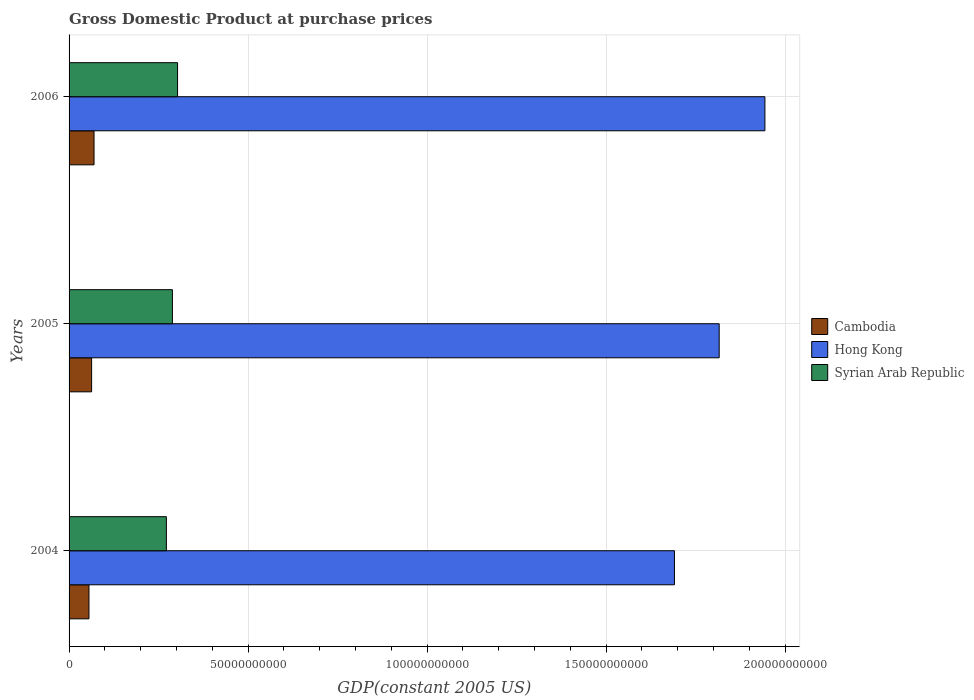Are the number of bars per tick equal to the number of legend labels?
Your response must be concise. Yes. How many bars are there on the 3rd tick from the top?
Keep it short and to the point. 3. How many bars are there on the 3rd tick from the bottom?
Offer a terse response. 3. In how many cases, is the number of bars for a given year not equal to the number of legend labels?
Offer a terse response. 0. What is the GDP at purchase prices in Syrian Arab Republic in 2006?
Offer a terse response. 3.03e+1. Across all years, what is the maximum GDP at purchase prices in Syrian Arab Republic?
Provide a succinct answer. 3.03e+1. Across all years, what is the minimum GDP at purchase prices in Syrian Arab Republic?
Ensure brevity in your answer.  2.72e+1. In which year was the GDP at purchase prices in Syrian Arab Republic maximum?
Keep it short and to the point. 2006. In which year was the GDP at purchase prices in Hong Kong minimum?
Offer a terse response. 2004. What is the total GDP at purchase prices in Hong Kong in the graph?
Your answer should be very brief. 5.45e+11. What is the difference between the GDP at purchase prices in Cambodia in 2005 and that in 2006?
Offer a very short reply. -6.78e+08. What is the difference between the GDP at purchase prices in Syrian Arab Republic in 2004 and the GDP at purchase prices in Cambodia in 2006?
Provide a short and direct response. 2.02e+1. What is the average GDP at purchase prices in Cambodia per year?
Give a very brief answer. 6.27e+09. In the year 2005, what is the difference between the GDP at purchase prices in Hong Kong and GDP at purchase prices in Syrian Arab Republic?
Give a very brief answer. 1.53e+11. In how many years, is the GDP at purchase prices in Cambodia greater than 190000000000 US$?
Your answer should be compact. 0. What is the ratio of the GDP at purchase prices in Hong Kong in 2005 to that in 2006?
Your response must be concise. 0.93. Is the GDP at purchase prices in Syrian Arab Republic in 2004 less than that in 2006?
Offer a terse response. Yes. Is the difference between the GDP at purchase prices in Hong Kong in 2005 and 2006 greater than the difference between the GDP at purchase prices in Syrian Arab Republic in 2005 and 2006?
Your answer should be compact. No. What is the difference between the highest and the second highest GDP at purchase prices in Cambodia?
Your answer should be very brief. 6.78e+08. What is the difference between the highest and the lowest GDP at purchase prices in Syrian Arab Republic?
Offer a terse response. 3.13e+09. In how many years, is the GDP at purchase prices in Hong Kong greater than the average GDP at purchase prices in Hong Kong taken over all years?
Make the answer very short. 1. Is the sum of the GDP at purchase prices in Cambodia in 2004 and 2005 greater than the maximum GDP at purchase prices in Hong Kong across all years?
Your response must be concise. No. What does the 3rd bar from the top in 2005 represents?
Your answer should be compact. Cambodia. What does the 1st bar from the bottom in 2004 represents?
Your answer should be compact. Cambodia. How many bars are there?
Give a very brief answer. 9. How many years are there in the graph?
Provide a succinct answer. 3. Are the values on the major ticks of X-axis written in scientific E-notation?
Offer a terse response. No. How are the legend labels stacked?
Offer a terse response. Vertical. What is the title of the graph?
Keep it short and to the point. Gross Domestic Product at purchase prices. What is the label or title of the X-axis?
Your answer should be very brief. GDP(constant 2005 US). What is the GDP(constant 2005 US) in Cambodia in 2004?
Provide a short and direct response. 5.56e+09. What is the GDP(constant 2005 US) of Hong Kong in 2004?
Ensure brevity in your answer.  1.69e+11. What is the GDP(constant 2005 US) in Syrian Arab Republic in 2004?
Keep it short and to the point. 2.72e+1. What is the GDP(constant 2005 US) of Cambodia in 2005?
Make the answer very short. 6.29e+09. What is the GDP(constant 2005 US) in Hong Kong in 2005?
Make the answer very short. 1.82e+11. What is the GDP(constant 2005 US) in Syrian Arab Republic in 2005?
Keep it short and to the point. 2.89e+1. What is the GDP(constant 2005 US) of Cambodia in 2006?
Provide a succinct answer. 6.97e+09. What is the GDP(constant 2005 US) in Hong Kong in 2006?
Provide a short and direct response. 1.94e+11. What is the GDP(constant 2005 US) in Syrian Arab Republic in 2006?
Make the answer very short. 3.03e+1. Across all years, what is the maximum GDP(constant 2005 US) in Cambodia?
Give a very brief answer. 6.97e+09. Across all years, what is the maximum GDP(constant 2005 US) of Hong Kong?
Your answer should be very brief. 1.94e+11. Across all years, what is the maximum GDP(constant 2005 US) of Syrian Arab Republic?
Provide a succinct answer. 3.03e+1. Across all years, what is the minimum GDP(constant 2005 US) of Cambodia?
Make the answer very short. 5.56e+09. Across all years, what is the minimum GDP(constant 2005 US) in Hong Kong?
Your answer should be compact. 1.69e+11. Across all years, what is the minimum GDP(constant 2005 US) in Syrian Arab Republic?
Make the answer very short. 2.72e+1. What is the total GDP(constant 2005 US) in Cambodia in the graph?
Keep it short and to the point. 1.88e+1. What is the total GDP(constant 2005 US) of Hong Kong in the graph?
Provide a short and direct response. 5.45e+11. What is the total GDP(constant 2005 US) in Syrian Arab Republic in the graph?
Provide a short and direct response. 8.63e+1. What is the difference between the GDP(constant 2005 US) in Cambodia in 2004 and that in 2005?
Ensure brevity in your answer.  -7.36e+08. What is the difference between the GDP(constant 2005 US) in Hong Kong in 2004 and that in 2005?
Offer a terse response. -1.25e+1. What is the difference between the GDP(constant 2005 US) of Syrian Arab Republic in 2004 and that in 2005?
Provide a succinct answer. -1.68e+09. What is the difference between the GDP(constant 2005 US) in Cambodia in 2004 and that in 2006?
Offer a terse response. -1.41e+09. What is the difference between the GDP(constant 2005 US) of Hong Kong in 2004 and that in 2006?
Ensure brevity in your answer.  -2.53e+1. What is the difference between the GDP(constant 2005 US) of Syrian Arab Republic in 2004 and that in 2006?
Provide a short and direct response. -3.13e+09. What is the difference between the GDP(constant 2005 US) of Cambodia in 2005 and that in 2006?
Ensure brevity in your answer.  -6.78e+08. What is the difference between the GDP(constant 2005 US) in Hong Kong in 2005 and that in 2006?
Give a very brief answer. -1.28e+1. What is the difference between the GDP(constant 2005 US) in Syrian Arab Republic in 2005 and that in 2006?
Make the answer very short. -1.44e+09. What is the difference between the GDP(constant 2005 US) of Cambodia in 2004 and the GDP(constant 2005 US) of Hong Kong in 2005?
Give a very brief answer. -1.76e+11. What is the difference between the GDP(constant 2005 US) of Cambodia in 2004 and the GDP(constant 2005 US) of Syrian Arab Republic in 2005?
Offer a very short reply. -2.33e+1. What is the difference between the GDP(constant 2005 US) of Hong Kong in 2004 and the GDP(constant 2005 US) of Syrian Arab Republic in 2005?
Your answer should be very brief. 1.40e+11. What is the difference between the GDP(constant 2005 US) of Cambodia in 2004 and the GDP(constant 2005 US) of Hong Kong in 2006?
Give a very brief answer. -1.89e+11. What is the difference between the GDP(constant 2005 US) of Cambodia in 2004 and the GDP(constant 2005 US) of Syrian Arab Republic in 2006?
Offer a very short reply. -2.47e+1. What is the difference between the GDP(constant 2005 US) of Hong Kong in 2004 and the GDP(constant 2005 US) of Syrian Arab Republic in 2006?
Your answer should be very brief. 1.39e+11. What is the difference between the GDP(constant 2005 US) in Cambodia in 2005 and the GDP(constant 2005 US) in Hong Kong in 2006?
Provide a succinct answer. -1.88e+11. What is the difference between the GDP(constant 2005 US) in Cambodia in 2005 and the GDP(constant 2005 US) in Syrian Arab Republic in 2006?
Offer a very short reply. -2.40e+1. What is the difference between the GDP(constant 2005 US) of Hong Kong in 2005 and the GDP(constant 2005 US) of Syrian Arab Republic in 2006?
Make the answer very short. 1.51e+11. What is the average GDP(constant 2005 US) in Cambodia per year?
Your response must be concise. 6.27e+09. What is the average GDP(constant 2005 US) of Hong Kong per year?
Provide a short and direct response. 1.82e+11. What is the average GDP(constant 2005 US) in Syrian Arab Republic per year?
Keep it short and to the point. 2.88e+1. In the year 2004, what is the difference between the GDP(constant 2005 US) in Cambodia and GDP(constant 2005 US) in Hong Kong?
Provide a short and direct response. -1.64e+11. In the year 2004, what is the difference between the GDP(constant 2005 US) of Cambodia and GDP(constant 2005 US) of Syrian Arab Republic?
Make the answer very short. -2.16e+1. In the year 2004, what is the difference between the GDP(constant 2005 US) in Hong Kong and GDP(constant 2005 US) in Syrian Arab Republic?
Offer a very short reply. 1.42e+11. In the year 2005, what is the difference between the GDP(constant 2005 US) in Cambodia and GDP(constant 2005 US) in Hong Kong?
Offer a very short reply. -1.75e+11. In the year 2005, what is the difference between the GDP(constant 2005 US) in Cambodia and GDP(constant 2005 US) in Syrian Arab Republic?
Make the answer very short. -2.26e+1. In the year 2005, what is the difference between the GDP(constant 2005 US) in Hong Kong and GDP(constant 2005 US) in Syrian Arab Republic?
Provide a succinct answer. 1.53e+11. In the year 2006, what is the difference between the GDP(constant 2005 US) of Cambodia and GDP(constant 2005 US) of Hong Kong?
Offer a terse response. -1.87e+11. In the year 2006, what is the difference between the GDP(constant 2005 US) in Cambodia and GDP(constant 2005 US) in Syrian Arab Republic?
Ensure brevity in your answer.  -2.33e+1. In the year 2006, what is the difference between the GDP(constant 2005 US) in Hong Kong and GDP(constant 2005 US) in Syrian Arab Republic?
Keep it short and to the point. 1.64e+11. What is the ratio of the GDP(constant 2005 US) in Cambodia in 2004 to that in 2005?
Provide a succinct answer. 0.88. What is the ratio of the GDP(constant 2005 US) of Hong Kong in 2004 to that in 2005?
Ensure brevity in your answer.  0.93. What is the ratio of the GDP(constant 2005 US) of Syrian Arab Republic in 2004 to that in 2005?
Make the answer very short. 0.94. What is the ratio of the GDP(constant 2005 US) of Cambodia in 2004 to that in 2006?
Your answer should be compact. 0.8. What is the ratio of the GDP(constant 2005 US) of Hong Kong in 2004 to that in 2006?
Ensure brevity in your answer.  0.87. What is the ratio of the GDP(constant 2005 US) of Syrian Arab Republic in 2004 to that in 2006?
Give a very brief answer. 0.9. What is the ratio of the GDP(constant 2005 US) of Cambodia in 2005 to that in 2006?
Offer a terse response. 0.9. What is the ratio of the GDP(constant 2005 US) in Hong Kong in 2005 to that in 2006?
Ensure brevity in your answer.  0.93. What is the ratio of the GDP(constant 2005 US) in Syrian Arab Republic in 2005 to that in 2006?
Give a very brief answer. 0.95. What is the difference between the highest and the second highest GDP(constant 2005 US) of Cambodia?
Offer a very short reply. 6.78e+08. What is the difference between the highest and the second highest GDP(constant 2005 US) of Hong Kong?
Your answer should be compact. 1.28e+1. What is the difference between the highest and the second highest GDP(constant 2005 US) of Syrian Arab Republic?
Make the answer very short. 1.44e+09. What is the difference between the highest and the lowest GDP(constant 2005 US) of Cambodia?
Offer a very short reply. 1.41e+09. What is the difference between the highest and the lowest GDP(constant 2005 US) of Hong Kong?
Your response must be concise. 2.53e+1. What is the difference between the highest and the lowest GDP(constant 2005 US) in Syrian Arab Republic?
Your answer should be very brief. 3.13e+09. 